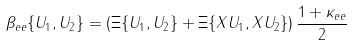Convert formula to latex. <formula><loc_0><loc_0><loc_500><loc_500>\beta _ { e e } \{ U _ { 1 } , U _ { 2 } \} = \left ( \Xi \{ U _ { 1 } , U _ { 2 } \} + \Xi \{ X U _ { 1 } , X U _ { 2 } \} \right ) \frac { 1 + \kappa _ { e e } } { 2 }</formula> 